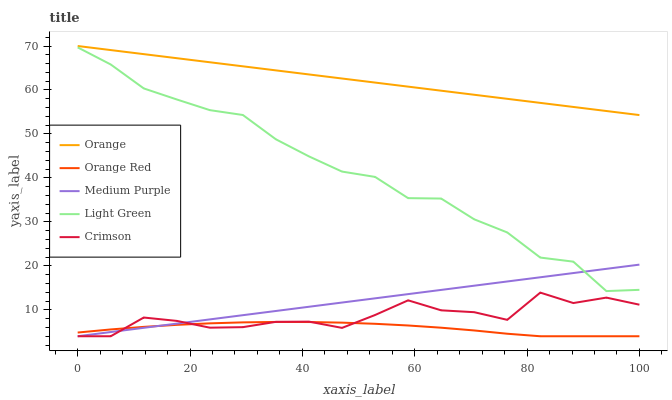Does Orange Red have the minimum area under the curve?
Answer yes or no. Yes. Does Orange have the maximum area under the curve?
Answer yes or no. Yes. Does Medium Purple have the minimum area under the curve?
Answer yes or no. No. Does Medium Purple have the maximum area under the curve?
Answer yes or no. No. Is Medium Purple the smoothest?
Answer yes or no. Yes. Is Crimson the roughest?
Answer yes or no. Yes. Is Crimson the smoothest?
Answer yes or no. No. Is Medium Purple the roughest?
Answer yes or no. No. Does Light Green have the lowest value?
Answer yes or no. No. Does Orange have the highest value?
Answer yes or no. Yes. Does Medium Purple have the highest value?
Answer yes or no. No. Is Crimson less than Orange?
Answer yes or no. Yes. Is Light Green greater than Orange Red?
Answer yes or no. Yes. Does Orange Red intersect Crimson?
Answer yes or no. Yes. Is Orange Red less than Crimson?
Answer yes or no. No. Is Orange Red greater than Crimson?
Answer yes or no. No. Does Crimson intersect Orange?
Answer yes or no. No. 